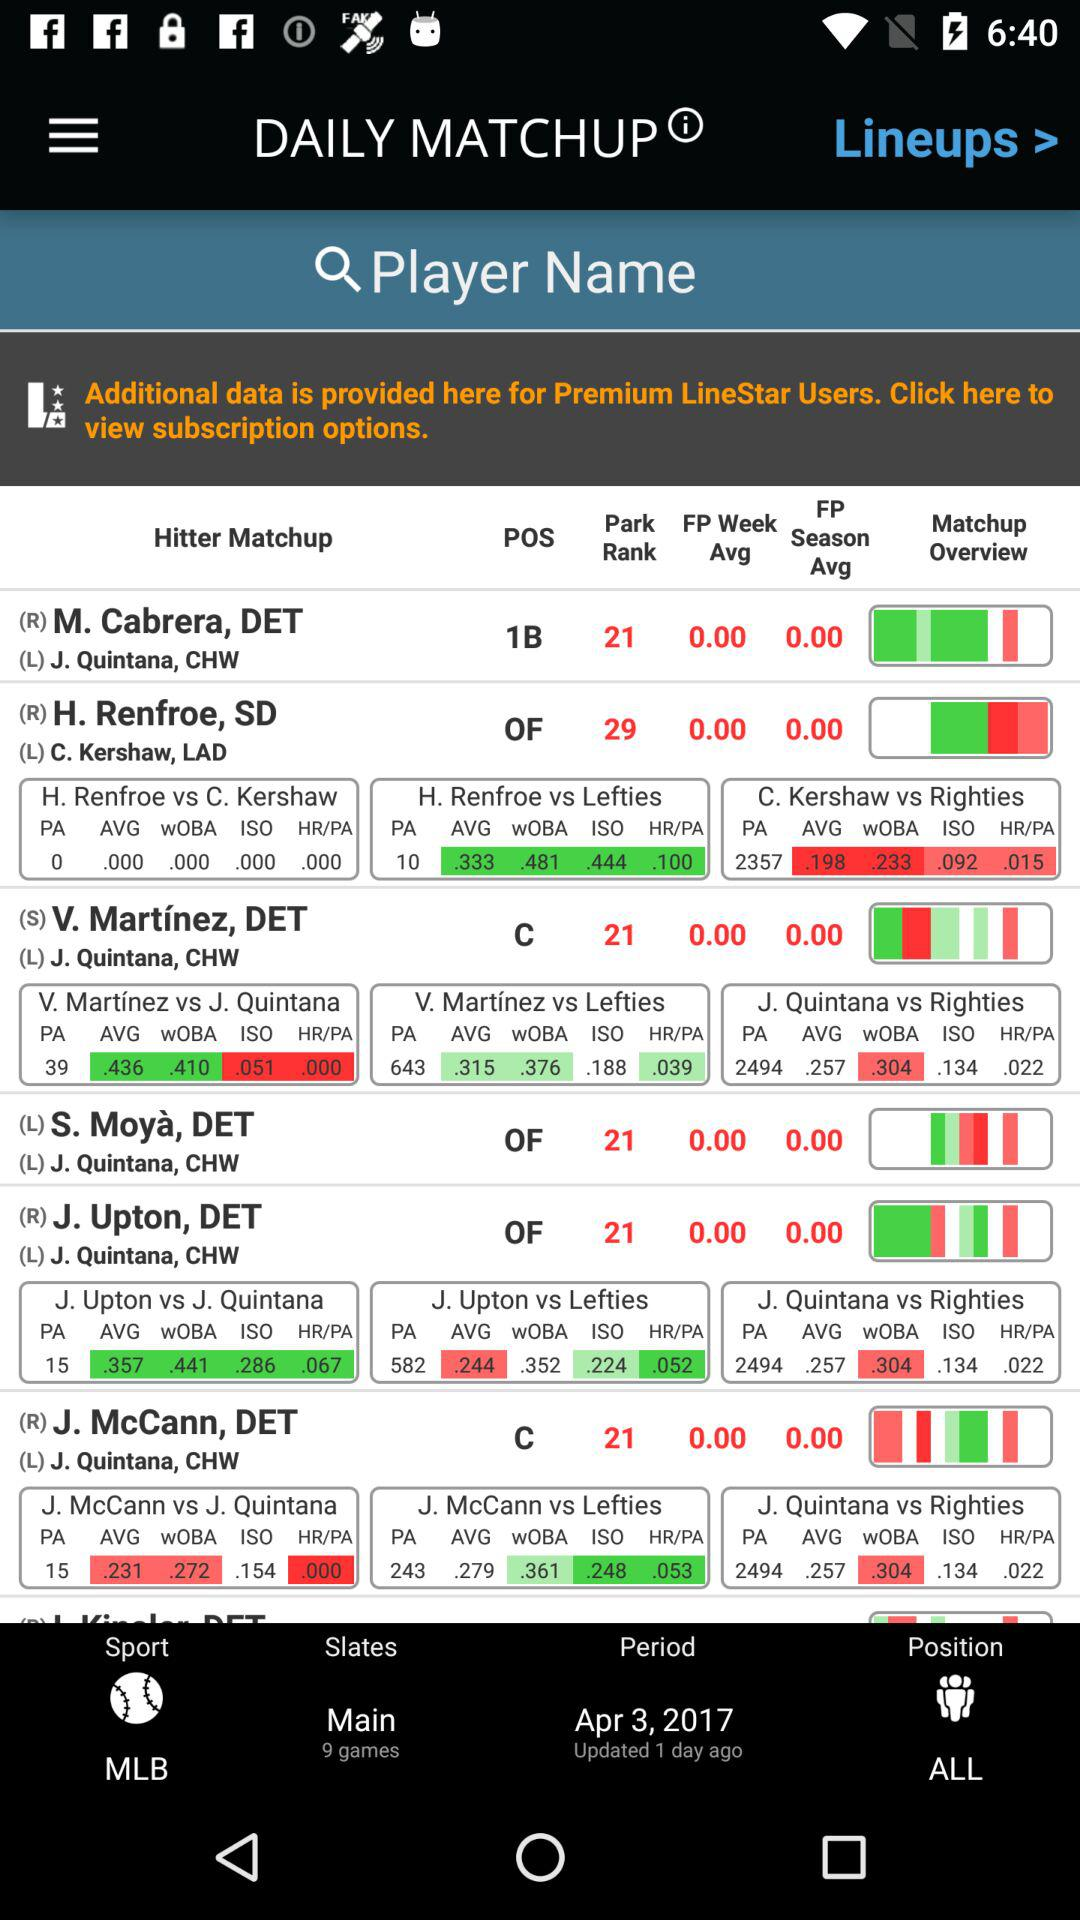When was the "Period" updated? The "Period" was updated 1 day ago. 